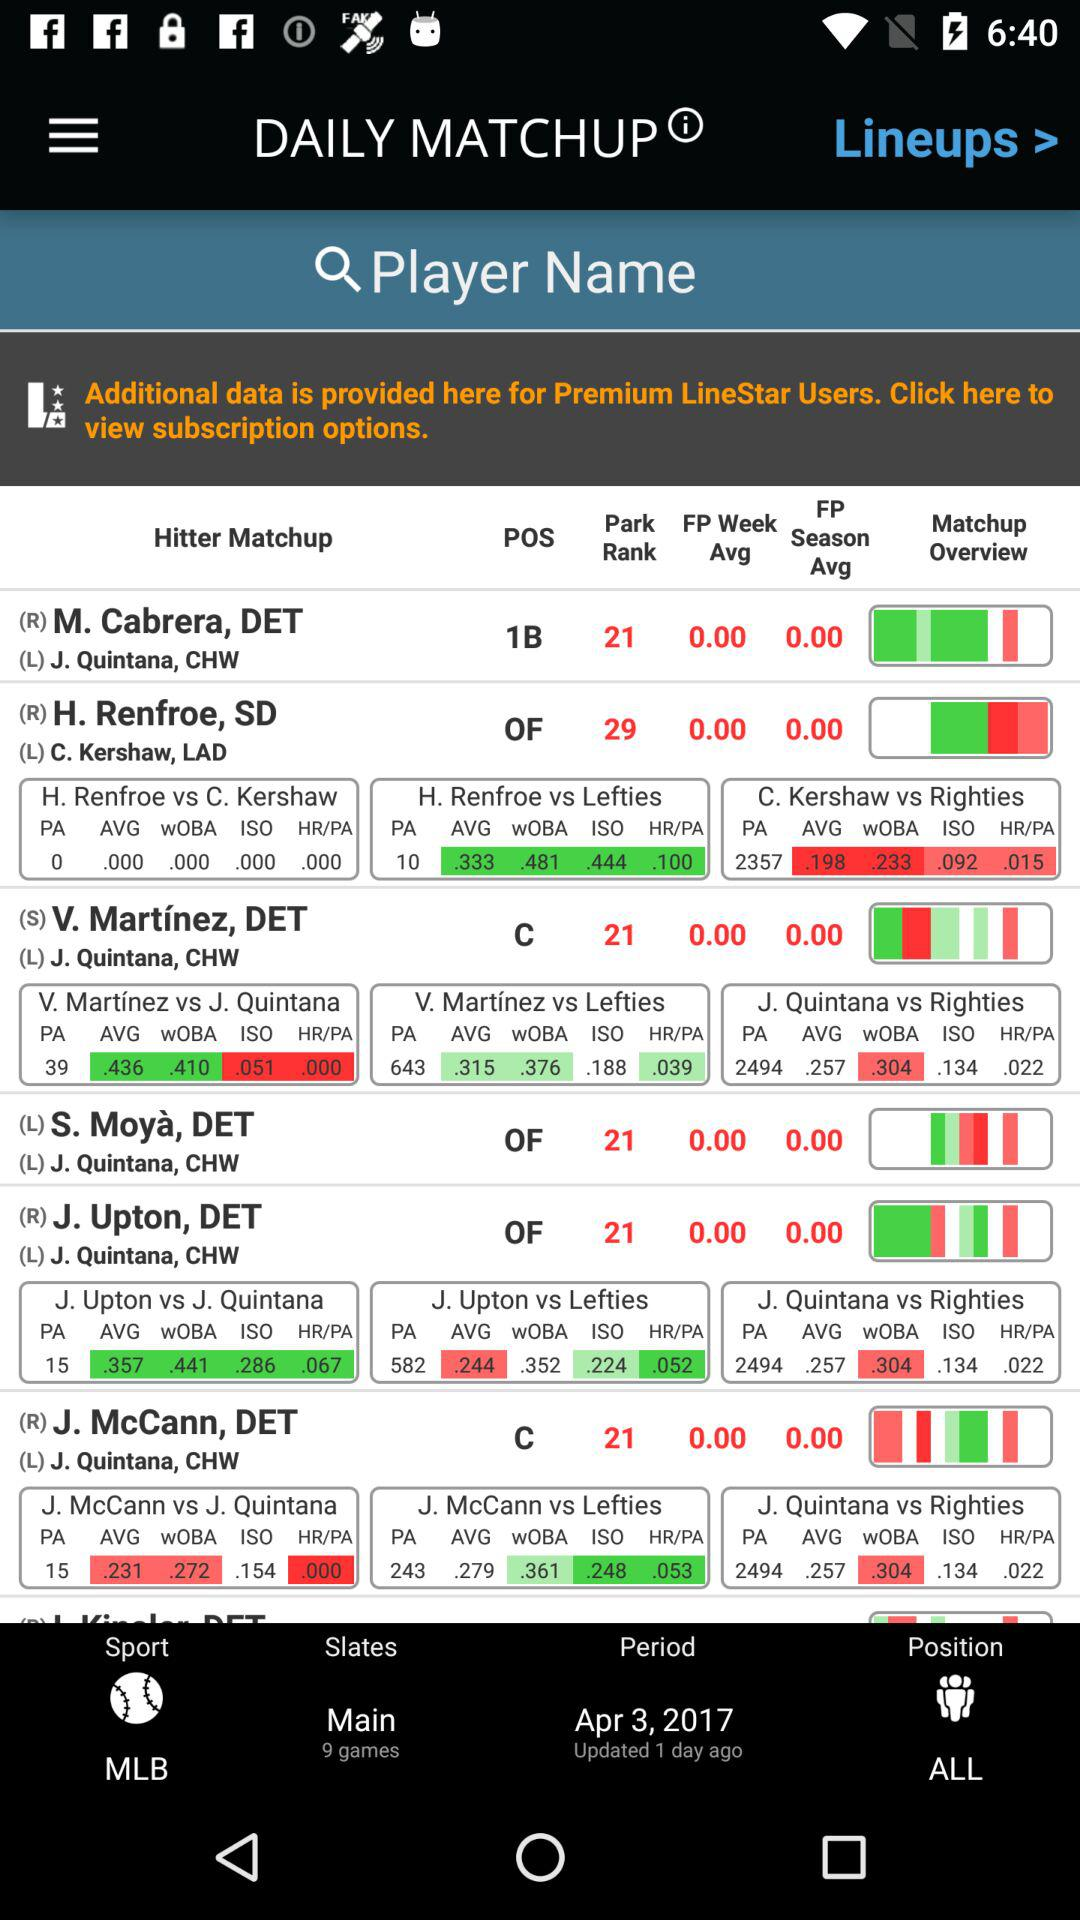When was the "Period" updated? The "Period" was updated 1 day ago. 